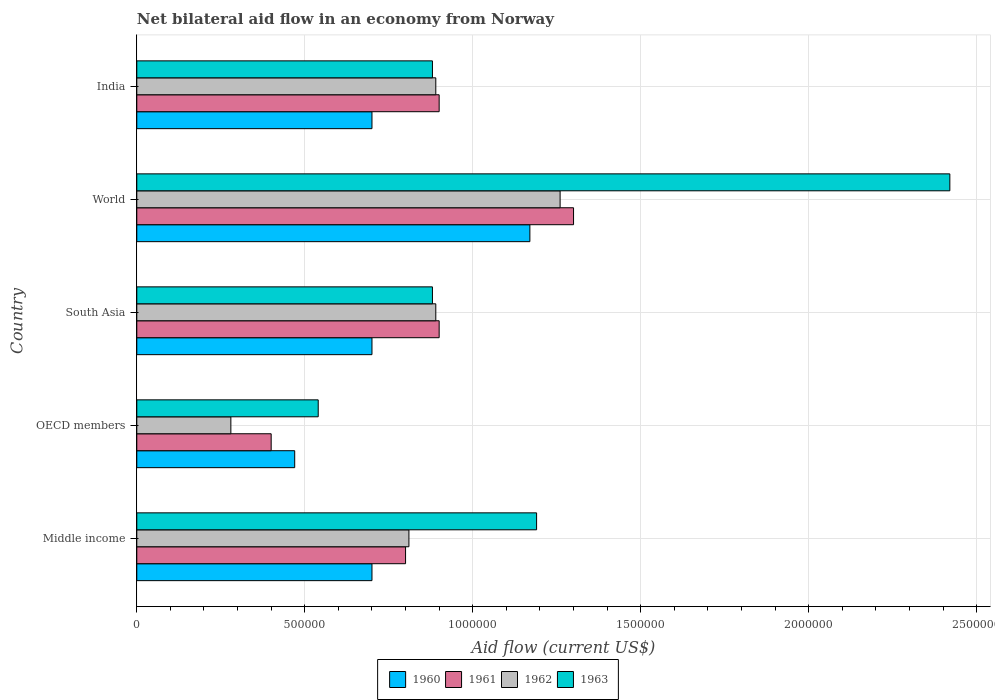Are the number of bars per tick equal to the number of legend labels?
Offer a terse response. Yes. Are the number of bars on each tick of the Y-axis equal?
Ensure brevity in your answer.  Yes. How many bars are there on the 2nd tick from the top?
Offer a very short reply. 4. What is the label of the 3rd group of bars from the top?
Provide a succinct answer. South Asia. What is the net bilateral aid flow in 1963 in India?
Your response must be concise. 8.80e+05. Across all countries, what is the maximum net bilateral aid flow in 1960?
Your response must be concise. 1.17e+06. What is the total net bilateral aid flow in 1960 in the graph?
Offer a terse response. 3.74e+06. What is the difference between the net bilateral aid flow in 1963 in Middle income and that in OECD members?
Offer a very short reply. 6.50e+05. What is the difference between the net bilateral aid flow in 1960 in OECD members and the net bilateral aid flow in 1961 in Middle income?
Provide a succinct answer. -3.30e+05. What is the average net bilateral aid flow in 1962 per country?
Your answer should be compact. 8.26e+05. What is the difference between the net bilateral aid flow in 1960 and net bilateral aid flow in 1962 in South Asia?
Your response must be concise. -1.90e+05. In how many countries, is the net bilateral aid flow in 1963 greater than 500000 US$?
Your response must be concise. 5. What is the ratio of the net bilateral aid flow in 1963 in OECD members to that in South Asia?
Keep it short and to the point. 0.61. Is the net bilateral aid flow in 1962 in OECD members less than that in South Asia?
Your answer should be very brief. Yes. Is the difference between the net bilateral aid flow in 1960 in Middle income and World greater than the difference between the net bilateral aid flow in 1962 in Middle income and World?
Give a very brief answer. No. Is the sum of the net bilateral aid flow in 1960 in India and World greater than the maximum net bilateral aid flow in 1963 across all countries?
Your answer should be compact. No. What does the 1st bar from the bottom in OECD members represents?
Your answer should be very brief. 1960. How many bars are there?
Your response must be concise. 20. How many countries are there in the graph?
Offer a very short reply. 5. Does the graph contain any zero values?
Offer a terse response. No. How many legend labels are there?
Your response must be concise. 4. What is the title of the graph?
Your answer should be compact. Net bilateral aid flow in an economy from Norway. What is the label or title of the Y-axis?
Provide a succinct answer. Country. What is the Aid flow (current US$) of 1960 in Middle income?
Provide a short and direct response. 7.00e+05. What is the Aid flow (current US$) of 1961 in Middle income?
Provide a succinct answer. 8.00e+05. What is the Aid flow (current US$) of 1962 in Middle income?
Make the answer very short. 8.10e+05. What is the Aid flow (current US$) in 1963 in Middle income?
Ensure brevity in your answer.  1.19e+06. What is the Aid flow (current US$) of 1963 in OECD members?
Offer a terse response. 5.40e+05. What is the Aid flow (current US$) of 1962 in South Asia?
Make the answer very short. 8.90e+05. What is the Aid flow (current US$) in 1963 in South Asia?
Make the answer very short. 8.80e+05. What is the Aid flow (current US$) of 1960 in World?
Give a very brief answer. 1.17e+06. What is the Aid flow (current US$) in 1961 in World?
Keep it short and to the point. 1.30e+06. What is the Aid flow (current US$) of 1962 in World?
Keep it short and to the point. 1.26e+06. What is the Aid flow (current US$) in 1963 in World?
Give a very brief answer. 2.42e+06. What is the Aid flow (current US$) of 1962 in India?
Offer a very short reply. 8.90e+05. What is the Aid flow (current US$) in 1963 in India?
Make the answer very short. 8.80e+05. Across all countries, what is the maximum Aid flow (current US$) in 1960?
Offer a terse response. 1.17e+06. Across all countries, what is the maximum Aid flow (current US$) in 1961?
Your response must be concise. 1.30e+06. Across all countries, what is the maximum Aid flow (current US$) of 1962?
Your answer should be compact. 1.26e+06. Across all countries, what is the maximum Aid flow (current US$) in 1963?
Make the answer very short. 2.42e+06. Across all countries, what is the minimum Aid flow (current US$) in 1960?
Provide a short and direct response. 4.70e+05. Across all countries, what is the minimum Aid flow (current US$) in 1961?
Offer a terse response. 4.00e+05. Across all countries, what is the minimum Aid flow (current US$) of 1963?
Your response must be concise. 5.40e+05. What is the total Aid flow (current US$) of 1960 in the graph?
Provide a succinct answer. 3.74e+06. What is the total Aid flow (current US$) in 1961 in the graph?
Your response must be concise. 4.30e+06. What is the total Aid flow (current US$) in 1962 in the graph?
Offer a very short reply. 4.13e+06. What is the total Aid flow (current US$) of 1963 in the graph?
Provide a succinct answer. 5.91e+06. What is the difference between the Aid flow (current US$) in 1960 in Middle income and that in OECD members?
Your response must be concise. 2.30e+05. What is the difference between the Aid flow (current US$) in 1961 in Middle income and that in OECD members?
Your response must be concise. 4.00e+05. What is the difference between the Aid flow (current US$) in 1962 in Middle income and that in OECD members?
Your answer should be very brief. 5.30e+05. What is the difference between the Aid flow (current US$) of 1963 in Middle income and that in OECD members?
Offer a terse response. 6.50e+05. What is the difference between the Aid flow (current US$) in 1960 in Middle income and that in South Asia?
Keep it short and to the point. 0. What is the difference between the Aid flow (current US$) of 1960 in Middle income and that in World?
Give a very brief answer. -4.70e+05. What is the difference between the Aid flow (current US$) in 1961 in Middle income and that in World?
Offer a very short reply. -5.00e+05. What is the difference between the Aid flow (current US$) of 1962 in Middle income and that in World?
Give a very brief answer. -4.50e+05. What is the difference between the Aid flow (current US$) of 1963 in Middle income and that in World?
Give a very brief answer. -1.23e+06. What is the difference between the Aid flow (current US$) in 1960 in Middle income and that in India?
Ensure brevity in your answer.  0. What is the difference between the Aid flow (current US$) in 1961 in Middle income and that in India?
Ensure brevity in your answer.  -1.00e+05. What is the difference between the Aid flow (current US$) in 1962 in Middle income and that in India?
Give a very brief answer. -8.00e+04. What is the difference between the Aid flow (current US$) in 1963 in Middle income and that in India?
Your answer should be compact. 3.10e+05. What is the difference between the Aid flow (current US$) of 1961 in OECD members and that in South Asia?
Offer a very short reply. -5.00e+05. What is the difference between the Aid flow (current US$) of 1962 in OECD members and that in South Asia?
Keep it short and to the point. -6.10e+05. What is the difference between the Aid flow (current US$) of 1963 in OECD members and that in South Asia?
Make the answer very short. -3.40e+05. What is the difference between the Aid flow (current US$) of 1960 in OECD members and that in World?
Your answer should be compact. -7.00e+05. What is the difference between the Aid flow (current US$) of 1961 in OECD members and that in World?
Give a very brief answer. -9.00e+05. What is the difference between the Aid flow (current US$) of 1962 in OECD members and that in World?
Your response must be concise. -9.80e+05. What is the difference between the Aid flow (current US$) in 1963 in OECD members and that in World?
Give a very brief answer. -1.88e+06. What is the difference between the Aid flow (current US$) in 1961 in OECD members and that in India?
Your answer should be very brief. -5.00e+05. What is the difference between the Aid flow (current US$) of 1962 in OECD members and that in India?
Your response must be concise. -6.10e+05. What is the difference between the Aid flow (current US$) in 1960 in South Asia and that in World?
Your response must be concise. -4.70e+05. What is the difference between the Aid flow (current US$) in 1961 in South Asia and that in World?
Give a very brief answer. -4.00e+05. What is the difference between the Aid flow (current US$) in 1962 in South Asia and that in World?
Provide a short and direct response. -3.70e+05. What is the difference between the Aid flow (current US$) in 1963 in South Asia and that in World?
Provide a succinct answer. -1.54e+06. What is the difference between the Aid flow (current US$) of 1961 in South Asia and that in India?
Keep it short and to the point. 0. What is the difference between the Aid flow (current US$) of 1962 in South Asia and that in India?
Keep it short and to the point. 0. What is the difference between the Aid flow (current US$) of 1963 in South Asia and that in India?
Give a very brief answer. 0. What is the difference between the Aid flow (current US$) of 1961 in World and that in India?
Your response must be concise. 4.00e+05. What is the difference between the Aid flow (current US$) of 1962 in World and that in India?
Ensure brevity in your answer.  3.70e+05. What is the difference between the Aid flow (current US$) in 1963 in World and that in India?
Your response must be concise. 1.54e+06. What is the difference between the Aid flow (current US$) of 1960 in Middle income and the Aid flow (current US$) of 1961 in OECD members?
Offer a very short reply. 3.00e+05. What is the difference between the Aid flow (current US$) in 1960 in Middle income and the Aid flow (current US$) in 1963 in OECD members?
Provide a succinct answer. 1.60e+05. What is the difference between the Aid flow (current US$) in 1961 in Middle income and the Aid flow (current US$) in 1962 in OECD members?
Keep it short and to the point. 5.20e+05. What is the difference between the Aid flow (current US$) of 1961 in Middle income and the Aid flow (current US$) of 1963 in OECD members?
Give a very brief answer. 2.60e+05. What is the difference between the Aid flow (current US$) in 1962 in Middle income and the Aid flow (current US$) in 1963 in OECD members?
Your answer should be very brief. 2.70e+05. What is the difference between the Aid flow (current US$) of 1960 in Middle income and the Aid flow (current US$) of 1963 in South Asia?
Your response must be concise. -1.80e+05. What is the difference between the Aid flow (current US$) of 1961 in Middle income and the Aid flow (current US$) of 1963 in South Asia?
Make the answer very short. -8.00e+04. What is the difference between the Aid flow (current US$) in 1960 in Middle income and the Aid flow (current US$) in 1961 in World?
Give a very brief answer. -6.00e+05. What is the difference between the Aid flow (current US$) in 1960 in Middle income and the Aid flow (current US$) in 1962 in World?
Make the answer very short. -5.60e+05. What is the difference between the Aid flow (current US$) of 1960 in Middle income and the Aid flow (current US$) of 1963 in World?
Give a very brief answer. -1.72e+06. What is the difference between the Aid flow (current US$) in 1961 in Middle income and the Aid flow (current US$) in 1962 in World?
Offer a terse response. -4.60e+05. What is the difference between the Aid flow (current US$) of 1961 in Middle income and the Aid flow (current US$) of 1963 in World?
Your answer should be compact. -1.62e+06. What is the difference between the Aid flow (current US$) of 1962 in Middle income and the Aid flow (current US$) of 1963 in World?
Offer a very short reply. -1.61e+06. What is the difference between the Aid flow (current US$) of 1960 in Middle income and the Aid flow (current US$) of 1961 in India?
Keep it short and to the point. -2.00e+05. What is the difference between the Aid flow (current US$) of 1960 in Middle income and the Aid flow (current US$) of 1963 in India?
Ensure brevity in your answer.  -1.80e+05. What is the difference between the Aid flow (current US$) in 1962 in Middle income and the Aid flow (current US$) in 1963 in India?
Your answer should be compact. -7.00e+04. What is the difference between the Aid flow (current US$) of 1960 in OECD members and the Aid flow (current US$) of 1961 in South Asia?
Offer a terse response. -4.30e+05. What is the difference between the Aid flow (current US$) of 1960 in OECD members and the Aid flow (current US$) of 1962 in South Asia?
Keep it short and to the point. -4.20e+05. What is the difference between the Aid flow (current US$) in 1960 in OECD members and the Aid flow (current US$) in 1963 in South Asia?
Offer a very short reply. -4.10e+05. What is the difference between the Aid flow (current US$) in 1961 in OECD members and the Aid flow (current US$) in 1962 in South Asia?
Provide a succinct answer. -4.90e+05. What is the difference between the Aid flow (current US$) in 1961 in OECD members and the Aid flow (current US$) in 1963 in South Asia?
Your answer should be compact. -4.80e+05. What is the difference between the Aid flow (current US$) of 1962 in OECD members and the Aid flow (current US$) of 1963 in South Asia?
Provide a short and direct response. -6.00e+05. What is the difference between the Aid flow (current US$) of 1960 in OECD members and the Aid flow (current US$) of 1961 in World?
Offer a terse response. -8.30e+05. What is the difference between the Aid flow (current US$) in 1960 in OECD members and the Aid flow (current US$) in 1962 in World?
Your response must be concise. -7.90e+05. What is the difference between the Aid flow (current US$) in 1960 in OECD members and the Aid flow (current US$) in 1963 in World?
Ensure brevity in your answer.  -1.95e+06. What is the difference between the Aid flow (current US$) in 1961 in OECD members and the Aid flow (current US$) in 1962 in World?
Your response must be concise. -8.60e+05. What is the difference between the Aid flow (current US$) in 1961 in OECD members and the Aid flow (current US$) in 1963 in World?
Your answer should be very brief. -2.02e+06. What is the difference between the Aid flow (current US$) in 1962 in OECD members and the Aid flow (current US$) in 1963 in World?
Ensure brevity in your answer.  -2.14e+06. What is the difference between the Aid flow (current US$) in 1960 in OECD members and the Aid flow (current US$) in 1961 in India?
Your answer should be very brief. -4.30e+05. What is the difference between the Aid flow (current US$) of 1960 in OECD members and the Aid flow (current US$) of 1962 in India?
Make the answer very short. -4.20e+05. What is the difference between the Aid flow (current US$) in 1960 in OECD members and the Aid flow (current US$) in 1963 in India?
Your answer should be compact. -4.10e+05. What is the difference between the Aid flow (current US$) of 1961 in OECD members and the Aid flow (current US$) of 1962 in India?
Offer a very short reply. -4.90e+05. What is the difference between the Aid flow (current US$) of 1961 in OECD members and the Aid flow (current US$) of 1963 in India?
Provide a succinct answer. -4.80e+05. What is the difference between the Aid flow (current US$) in 1962 in OECD members and the Aid flow (current US$) in 1963 in India?
Your answer should be compact. -6.00e+05. What is the difference between the Aid flow (current US$) in 1960 in South Asia and the Aid flow (current US$) in 1961 in World?
Ensure brevity in your answer.  -6.00e+05. What is the difference between the Aid flow (current US$) of 1960 in South Asia and the Aid flow (current US$) of 1962 in World?
Your answer should be very brief. -5.60e+05. What is the difference between the Aid flow (current US$) of 1960 in South Asia and the Aid flow (current US$) of 1963 in World?
Offer a terse response. -1.72e+06. What is the difference between the Aid flow (current US$) in 1961 in South Asia and the Aid flow (current US$) in 1962 in World?
Your answer should be compact. -3.60e+05. What is the difference between the Aid flow (current US$) of 1961 in South Asia and the Aid flow (current US$) of 1963 in World?
Provide a succinct answer. -1.52e+06. What is the difference between the Aid flow (current US$) in 1962 in South Asia and the Aid flow (current US$) in 1963 in World?
Your response must be concise. -1.53e+06. What is the difference between the Aid flow (current US$) of 1960 in South Asia and the Aid flow (current US$) of 1963 in India?
Offer a terse response. -1.80e+05. What is the difference between the Aid flow (current US$) in 1961 in South Asia and the Aid flow (current US$) in 1962 in India?
Offer a terse response. 10000. What is the difference between the Aid flow (current US$) in 1961 in South Asia and the Aid flow (current US$) in 1963 in India?
Provide a short and direct response. 2.00e+04. What is the difference between the Aid flow (current US$) of 1960 in World and the Aid flow (current US$) of 1961 in India?
Offer a terse response. 2.70e+05. What is the difference between the Aid flow (current US$) of 1960 in World and the Aid flow (current US$) of 1963 in India?
Your answer should be very brief. 2.90e+05. What is the difference between the Aid flow (current US$) in 1962 in World and the Aid flow (current US$) in 1963 in India?
Offer a terse response. 3.80e+05. What is the average Aid flow (current US$) in 1960 per country?
Make the answer very short. 7.48e+05. What is the average Aid flow (current US$) in 1961 per country?
Ensure brevity in your answer.  8.60e+05. What is the average Aid flow (current US$) of 1962 per country?
Your response must be concise. 8.26e+05. What is the average Aid flow (current US$) of 1963 per country?
Make the answer very short. 1.18e+06. What is the difference between the Aid flow (current US$) of 1960 and Aid flow (current US$) of 1962 in Middle income?
Your answer should be very brief. -1.10e+05. What is the difference between the Aid flow (current US$) of 1960 and Aid flow (current US$) of 1963 in Middle income?
Offer a terse response. -4.90e+05. What is the difference between the Aid flow (current US$) in 1961 and Aid flow (current US$) in 1963 in Middle income?
Make the answer very short. -3.90e+05. What is the difference between the Aid flow (current US$) of 1962 and Aid flow (current US$) of 1963 in Middle income?
Your answer should be very brief. -3.80e+05. What is the difference between the Aid flow (current US$) of 1960 and Aid flow (current US$) of 1962 in OECD members?
Your response must be concise. 1.90e+05. What is the difference between the Aid flow (current US$) of 1960 and Aid flow (current US$) of 1963 in OECD members?
Your answer should be very brief. -7.00e+04. What is the difference between the Aid flow (current US$) in 1960 and Aid flow (current US$) in 1961 in South Asia?
Your answer should be very brief. -2.00e+05. What is the difference between the Aid flow (current US$) of 1960 and Aid flow (current US$) of 1963 in South Asia?
Give a very brief answer. -1.80e+05. What is the difference between the Aid flow (current US$) of 1961 and Aid flow (current US$) of 1962 in South Asia?
Provide a succinct answer. 10000. What is the difference between the Aid flow (current US$) of 1961 and Aid flow (current US$) of 1963 in South Asia?
Ensure brevity in your answer.  2.00e+04. What is the difference between the Aid flow (current US$) in 1962 and Aid flow (current US$) in 1963 in South Asia?
Offer a very short reply. 10000. What is the difference between the Aid flow (current US$) of 1960 and Aid flow (current US$) of 1962 in World?
Provide a short and direct response. -9.00e+04. What is the difference between the Aid flow (current US$) in 1960 and Aid flow (current US$) in 1963 in World?
Ensure brevity in your answer.  -1.25e+06. What is the difference between the Aid flow (current US$) in 1961 and Aid flow (current US$) in 1963 in World?
Give a very brief answer. -1.12e+06. What is the difference between the Aid flow (current US$) of 1962 and Aid flow (current US$) of 1963 in World?
Make the answer very short. -1.16e+06. What is the difference between the Aid flow (current US$) in 1960 and Aid flow (current US$) in 1962 in India?
Keep it short and to the point. -1.90e+05. What is the difference between the Aid flow (current US$) of 1961 and Aid flow (current US$) of 1962 in India?
Offer a very short reply. 10000. What is the difference between the Aid flow (current US$) of 1961 and Aid flow (current US$) of 1963 in India?
Offer a very short reply. 2.00e+04. What is the difference between the Aid flow (current US$) of 1962 and Aid flow (current US$) of 1963 in India?
Offer a terse response. 10000. What is the ratio of the Aid flow (current US$) in 1960 in Middle income to that in OECD members?
Your answer should be compact. 1.49. What is the ratio of the Aid flow (current US$) in 1962 in Middle income to that in OECD members?
Your answer should be very brief. 2.89. What is the ratio of the Aid flow (current US$) in 1963 in Middle income to that in OECD members?
Your answer should be compact. 2.2. What is the ratio of the Aid flow (current US$) of 1961 in Middle income to that in South Asia?
Offer a very short reply. 0.89. What is the ratio of the Aid flow (current US$) of 1962 in Middle income to that in South Asia?
Provide a short and direct response. 0.91. What is the ratio of the Aid flow (current US$) in 1963 in Middle income to that in South Asia?
Offer a very short reply. 1.35. What is the ratio of the Aid flow (current US$) of 1960 in Middle income to that in World?
Make the answer very short. 0.6. What is the ratio of the Aid flow (current US$) in 1961 in Middle income to that in World?
Keep it short and to the point. 0.62. What is the ratio of the Aid flow (current US$) in 1962 in Middle income to that in World?
Your response must be concise. 0.64. What is the ratio of the Aid flow (current US$) in 1963 in Middle income to that in World?
Ensure brevity in your answer.  0.49. What is the ratio of the Aid flow (current US$) of 1961 in Middle income to that in India?
Offer a very short reply. 0.89. What is the ratio of the Aid flow (current US$) of 1962 in Middle income to that in India?
Provide a succinct answer. 0.91. What is the ratio of the Aid flow (current US$) in 1963 in Middle income to that in India?
Your answer should be very brief. 1.35. What is the ratio of the Aid flow (current US$) in 1960 in OECD members to that in South Asia?
Your answer should be very brief. 0.67. What is the ratio of the Aid flow (current US$) in 1961 in OECD members to that in South Asia?
Your answer should be compact. 0.44. What is the ratio of the Aid flow (current US$) of 1962 in OECD members to that in South Asia?
Offer a very short reply. 0.31. What is the ratio of the Aid flow (current US$) of 1963 in OECD members to that in South Asia?
Your answer should be compact. 0.61. What is the ratio of the Aid flow (current US$) in 1960 in OECD members to that in World?
Offer a terse response. 0.4. What is the ratio of the Aid flow (current US$) of 1961 in OECD members to that in World?
Your response must be concise. 0.31. What is the ratio of the Aid flow (current US$) in 1962 in OECD members to that in World?
Provide a succinct answer. 0.22. What is the ratio of the Aid flow (current US$) of 1963 in OECD members to that in World?
Provide a short and direct response. 0.22. What is the ratio of the Aid flow (current US$) in 1960 in OECD members to that in India?
Give a very brief answer. 0.67. What is the ratio of the Aid flow (current US$) of 1961 in OECD members to that in India?
Offer a terse response. 0.44. What is the ratio of the Aid flow (current US$) in 1962 in OECD members to that in India?
Provide a succinct answer. 0.31. What is the ratio of the Aid flow (current US$) in 1963 in OECD members to that in India?
Your response must be concise. 0.61. What is the ratio of the Aid flow (current US$) in 1960 in South Asia to that in World?
Ensure brevity in your answer.  0.6. What is the ratio of the Aid flow (current US$) of 1961 in South Asia to that in World?
Your response must be concise. 0.69. What is the ratio of the Aid flow (current US$) in 1962 in South Asia to that in World?
Give a very brief answer. 0.71. What is the ratio of the Aid flow (current US$) of 1963 in South Asia to that in World?
Give a very brief answer. 0.36. What is the ratio of the Aid flow (current US$) in 1960 in South Asia to that in India?
Provide a short and direct response. 1. What is the ratio of the Aid flow (current US$) in 1961 in South Asia to that in India?
Give a very brief answer. 1. What is the ratio of the Aid flow (current US$) of 1963 in South Asia to that in India?
Your answer should be compact. 1. What is the ratio of the Aid flow (current US$) in 1960 in World to that in India?
Ensure brevity in your answer.  1.67. What is the ratio of the Aid flow (current US$) in 1961 in World to that in India?
Your answer should be very brief. 1.44. What is the ratio of the Aid flow (current US$) of 1962 in World to that in India?
Make the answer very short. 1.42. What is the ratio of the Aid flow (current US$) of 1963 in World to that in India?
Offer a terse response. 2.75. What is the difference between the highest and the second highest Aid flow (current US$) of 1961?
Your answer should be compact. 4.00e+05. What is the difference between the highest and the second highest Aid flow (current US$) in 1963?
Provide a short and direct response. 1.23e+06. What is the difference between the highest and the lowest Aid flow (current US$) in 1961?
Ensure brevity in your answer.  9.00e+05. What is the difference between the highest and the lowest Aid flow (current US$) of 1962?
Make the answer very short. 9.80e+05. What is the difference between the highest and the lowest Aid flow (current US$) of 1963?
Your answer should be compact. 1.88e+06. 